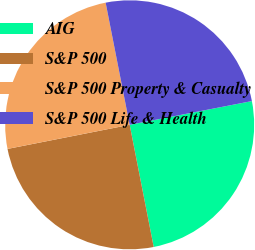Convert chart to OTSL. <chart><loc_0><loc_0><loc_500><loc_500><pie_chart><fcel>AIG<fcel>S&P 500<fcel>S&P 500 Property & Casualty<fcel>S&P 500 Life & Health<nl><fcel>24.96%<fcel>24.99%<fcel>25.01%<fcel>25.04%<nl></chart> 